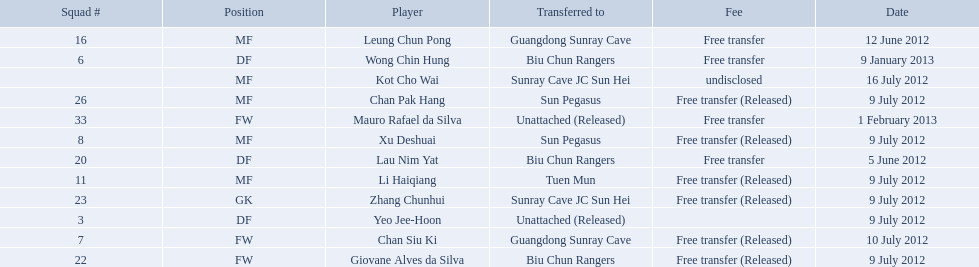On what dates were there non released free transfers? 5 June 2012, 12 June 2012, 9 January 2013, 1 February 2013. On which of these were the players transferred to another team? 5 June 2012, 12 June 2012, 9 January 2013. Which of these were the transfers to biu chun rangers? 5 June 2012, 9 January 2013. On which of those dated did they receive a df? 9 January 2013. 